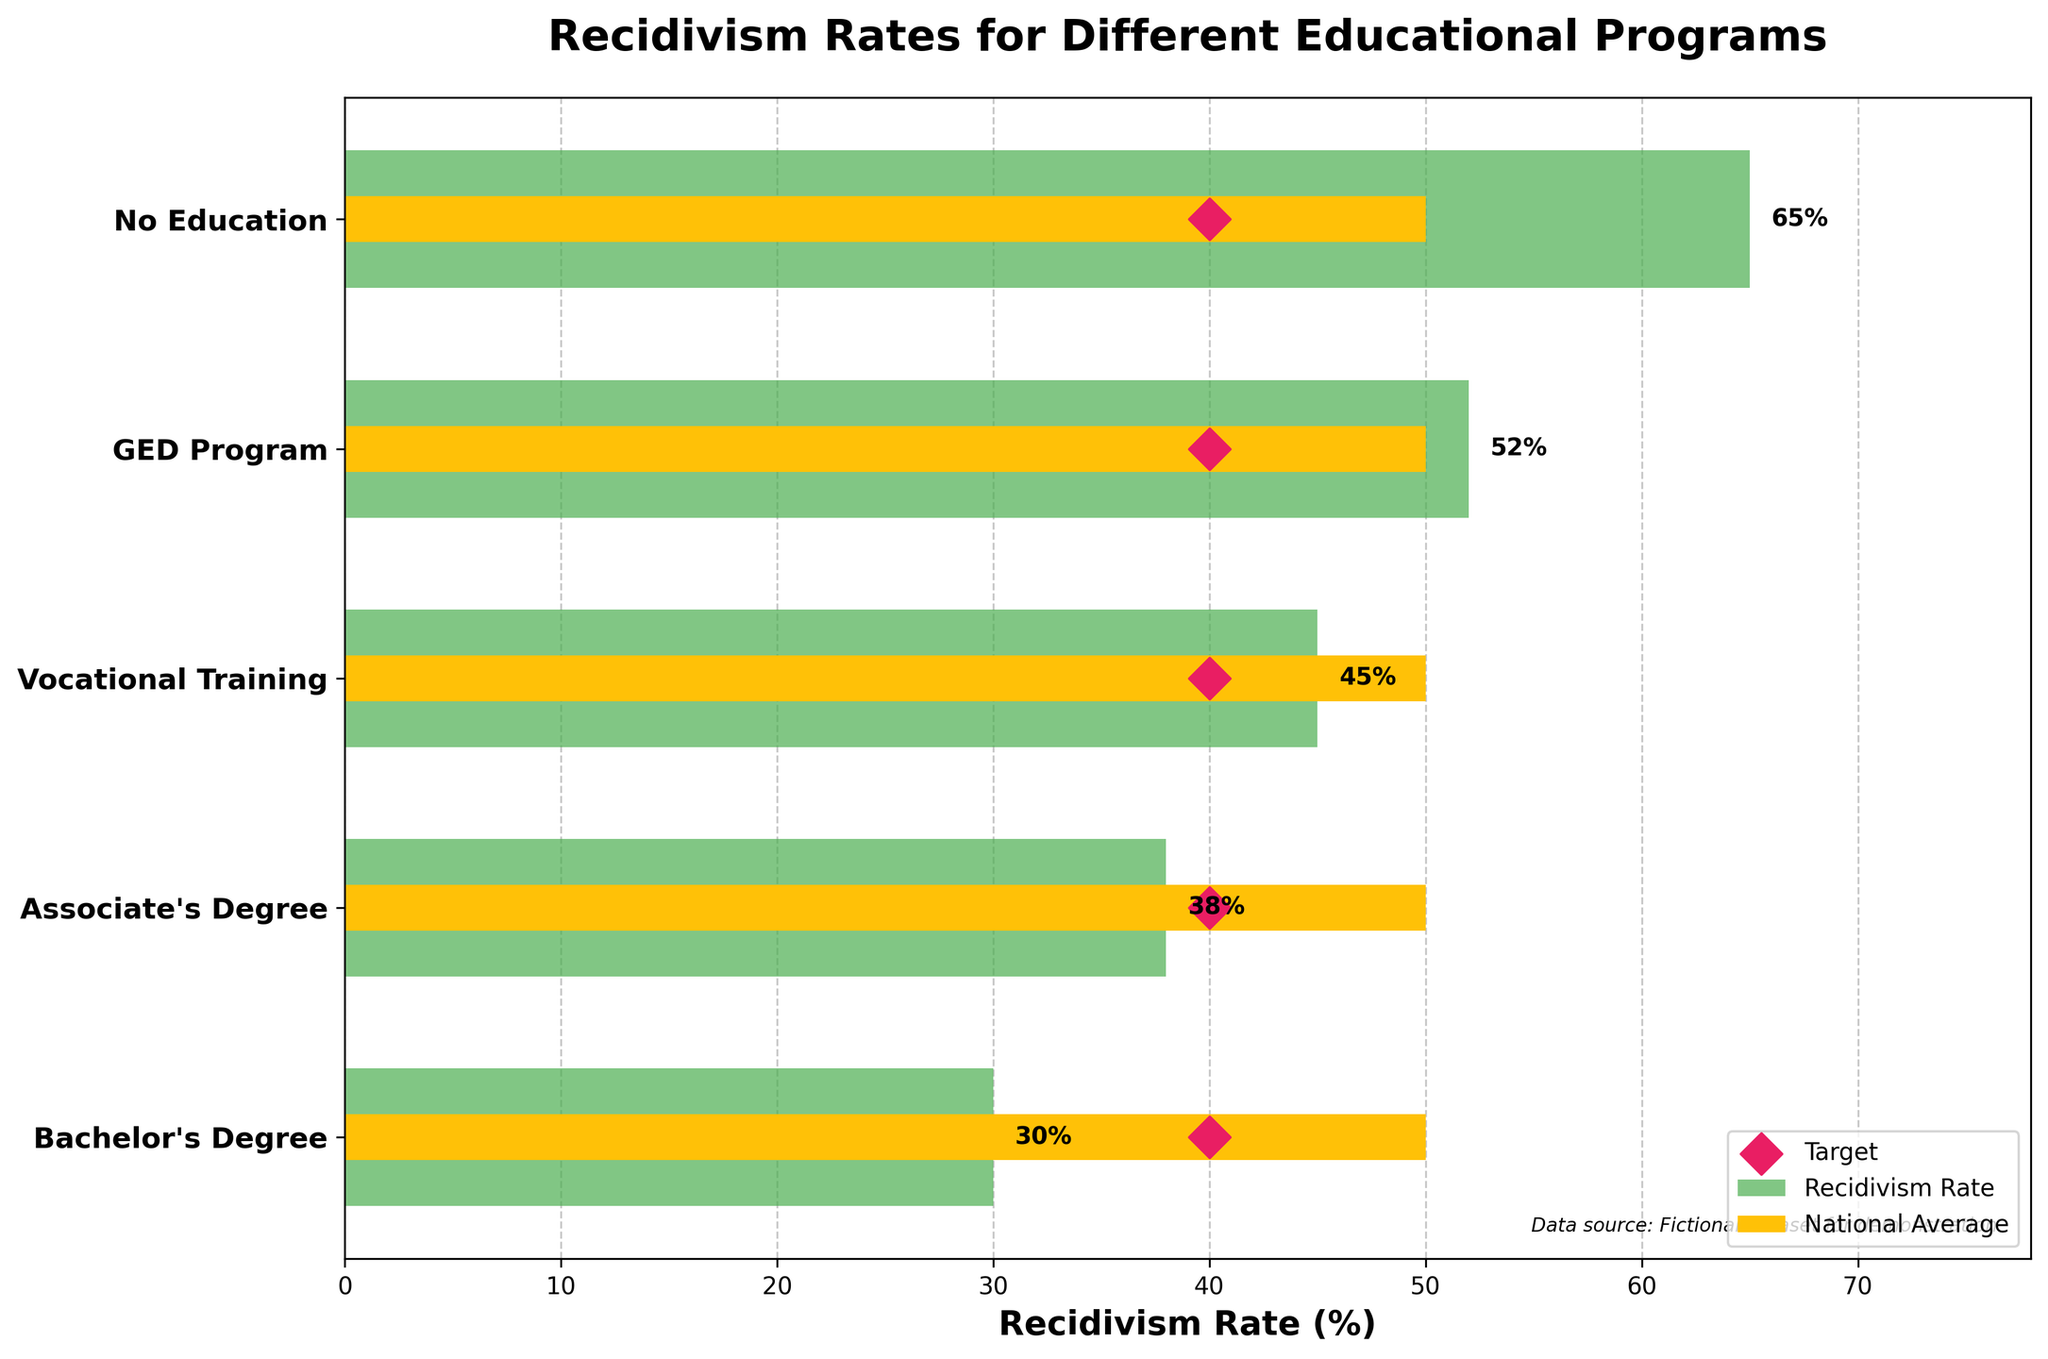What is the title of the figure? The title of the figure is often located at the top of the graph, representing the main theme or what the graph is illustrating. In this figure, it clearly states the subject of the data.
Answer: Recidivism Rates for Different Educational Programs How many educational programs are compared in the figure? Count the distinct program labels on the y-axis. Each label represents a different educational program offered to inmates.
Answer: 5 Which educational program shows the lowest recidivism rate? Look at the heights of the green bars or inspect the labeled percentage values next to each program. Select the one with the smallest value.
Answer: Bachelor's Degree How does the recidivism rate of the "GED Program" compare to the "Vocational Training" program? Identify the recidivism percentages next to both labels on the y-axis and compare these two values directly. The GED Program percentage is 52%, and the Vocational Training percentage is 45%.
Answer: The GED Program has a higher recidivism rate than the Vocational Training program What is the difference between the recidivism rate of inmates with no education and those with an Associate's Degree? Find the recidivism rates for both "No Education" (65%) and "Associate's Degree" (38%) and subtract the latter from the former.
Answer: 27% What is the target recidivism rate for all educational programs? Check all the diamond markers (representing targets) on the horizontal bars. These should align horizontally, indicating a universal target. Each program aims for the same target percentage.
Answer: 40% Is any educational program's recidivism rate below the national average? Compare each program's recidivism rate bar with the yellow bar (representing the national average, which is fixed at 50%). Identify if any green bars are entirely below this level.
Answer: Yes, Vocational Training, Associate's Degree, and Bachelor's Degree programs are below the national average What is the difference between the national average recidivism rate and the target rate? Identify the fixed national average (50%) and target percentage (40%). Subtract the target from the national average.
Answer: 10% What can be inferred about the effectiveness of higher education programs in reducing recidivism? Compare recidivism rates across educational programs, particularly noting how rates decrease from GED to Bachelor's Degree, and recognize the trend of decreasing recidivism with higher levels of education.
Answer: Higher education programs consistently reduce recidivism rates Which program comes closest to meeting the target rate? Compare the recidivism rates of each program to the target percentage of 40%. Identify which one has the smallest difference.
Answer: Bachelor's Degree 